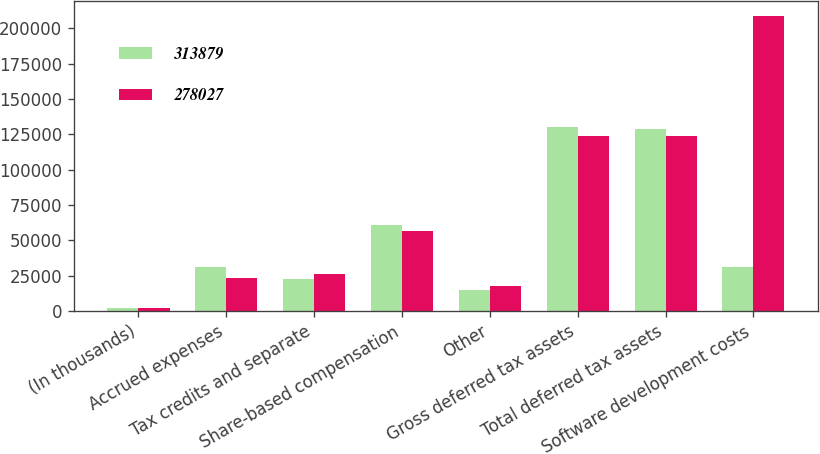Convert chart to OTSL. <chart><loc_0><loc_0><loc_500><loc_500><stacked_bar_chart><ecel><fcel>(In thousands)<fcel>Accrued expenses<fcel>Tax credits and separate<fcel>Share-based compensation<fcel>Other<fcel>Gross deferred tax assets<fcel>Total deferred tax assets<fcel>Software development costs<nl><fcel>313879<fcel>2018<fcel>31273<fcel>22826<fcel>60901<fcel>14951<fcel>129951<fcel>128547<fcel>31273<nl><fcel>278027<fcel>2017<fcel>23295<fcel>26304<fcel>56263<fcel>17754<fcel>123616<fcel>123616<fcel>208494<nl></chart> 